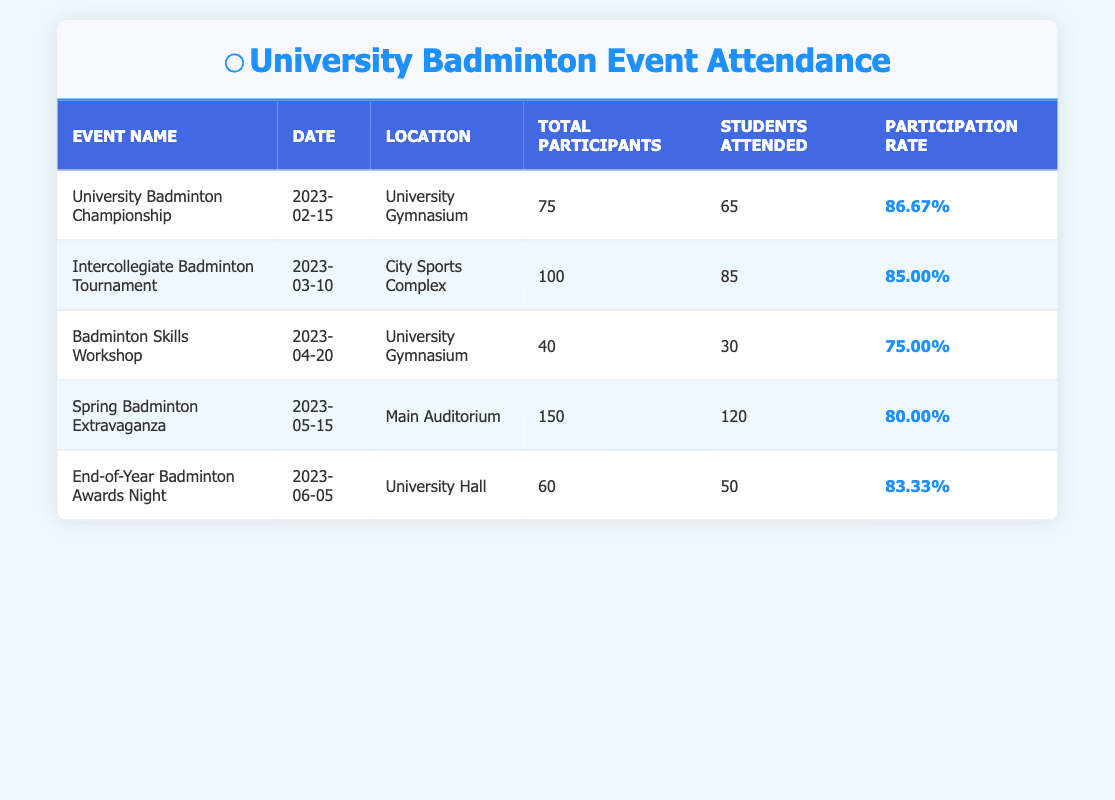What was the participation rate for the University Badminton Championship? The participation rate for the University Badminton Championship is directly taken from the table where it lists 86.67% as the participation rate.
Answer: 86.67% How many students attended the Spring Badminton Extravaganza? From the table, the number of students who attended the Spring Badminton Extravaganza is 120.
Answer: 120 Which event had the lowest total participants? By examining the 'Total Participants' column, the Badminton Skills Workshop had the lowest total with 40 participants compared to others.
Answer: Badminton Skills Workshop What is the average participation rate of all events listed? To find the average participation rate, sum all participation rates (86.67 + 85.00 + 75.00 + 80.00 + 83.33) = 410.00, and then divide by the number of events (5), which equals 410.00 / 5 = 82.00.
Answer: 82.00 Was the participation rate for the End-of-Year Badminton Awards Night above 80%? The participation rate for the End-of-Year Badminton Awards Night is listed as 83.33%, which is indeed above 80%.
Answer: Yes Which event had a higher attendance rate, the Intercollegiate Badminton Tournament or the Spring Badminton Extravaganza? The participation rate for the Intercollegiate Badminton Tournament is 85.00%, while the Spring Badminton Extravaganza is 80.00%. Since 85.00% is greater than 80.00%, the Intercollegiate Badminton Tournament had a higher attendance rate.
Answer: Intercollegiate Badminton Tournament How many students did not attend the Badminton Skills Workshop? The total participants for the Badminton Skills Workshop are 40, and the students who attended are 30. To find the number of students who did not attend, subtract: 40 - 30 = 10.
Answer: 10 What percentage of students attended the End-of-Year Badminton Awards Night compared to the total participants? The number of students attended is 50, and the total participants are 60. To find the percentage, calculate (50/60) * 100 = 83.33%. This value matches the event's participation rate, confirming accuracy.
Answer: 83.33% Which event had the greatest attendance number, and how many students attended? Looking at the 'Students Attended' column, the Spring Badminton Extravaganza had the highest attendance with 120 students attending the event.
Answer: Spring Badminton Extravaganza, 120 